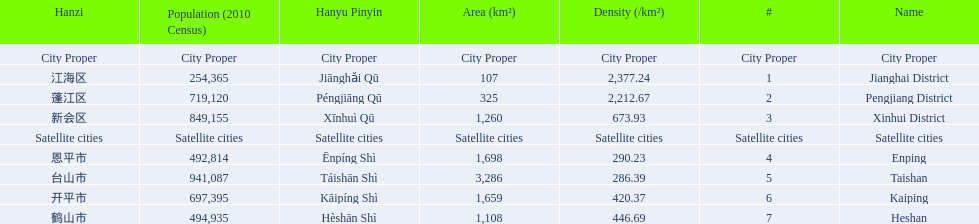What cities are there in jiangmen? Jianghai District, Pengjiang District, Xinhui District, Enping, Taishan, Kaiping, Heshan. Of those, which ones are a city proper? Jianghai District, Pengjiang District, Xinhui District. Of those, which one has the smallest area in km2? Jianghai District. 